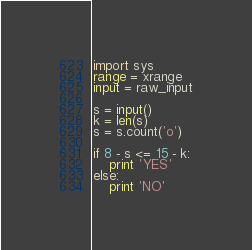<code> <loc_0><loc_0><loc_500><loc_500><_Python_>import sys
range = xrange
input = raw_input

s = input()
k = len(s)
s = s.count('o')

if 8 - s <= 15 - k:
    print 'YES'
else:
    print 'NO'
</code> 